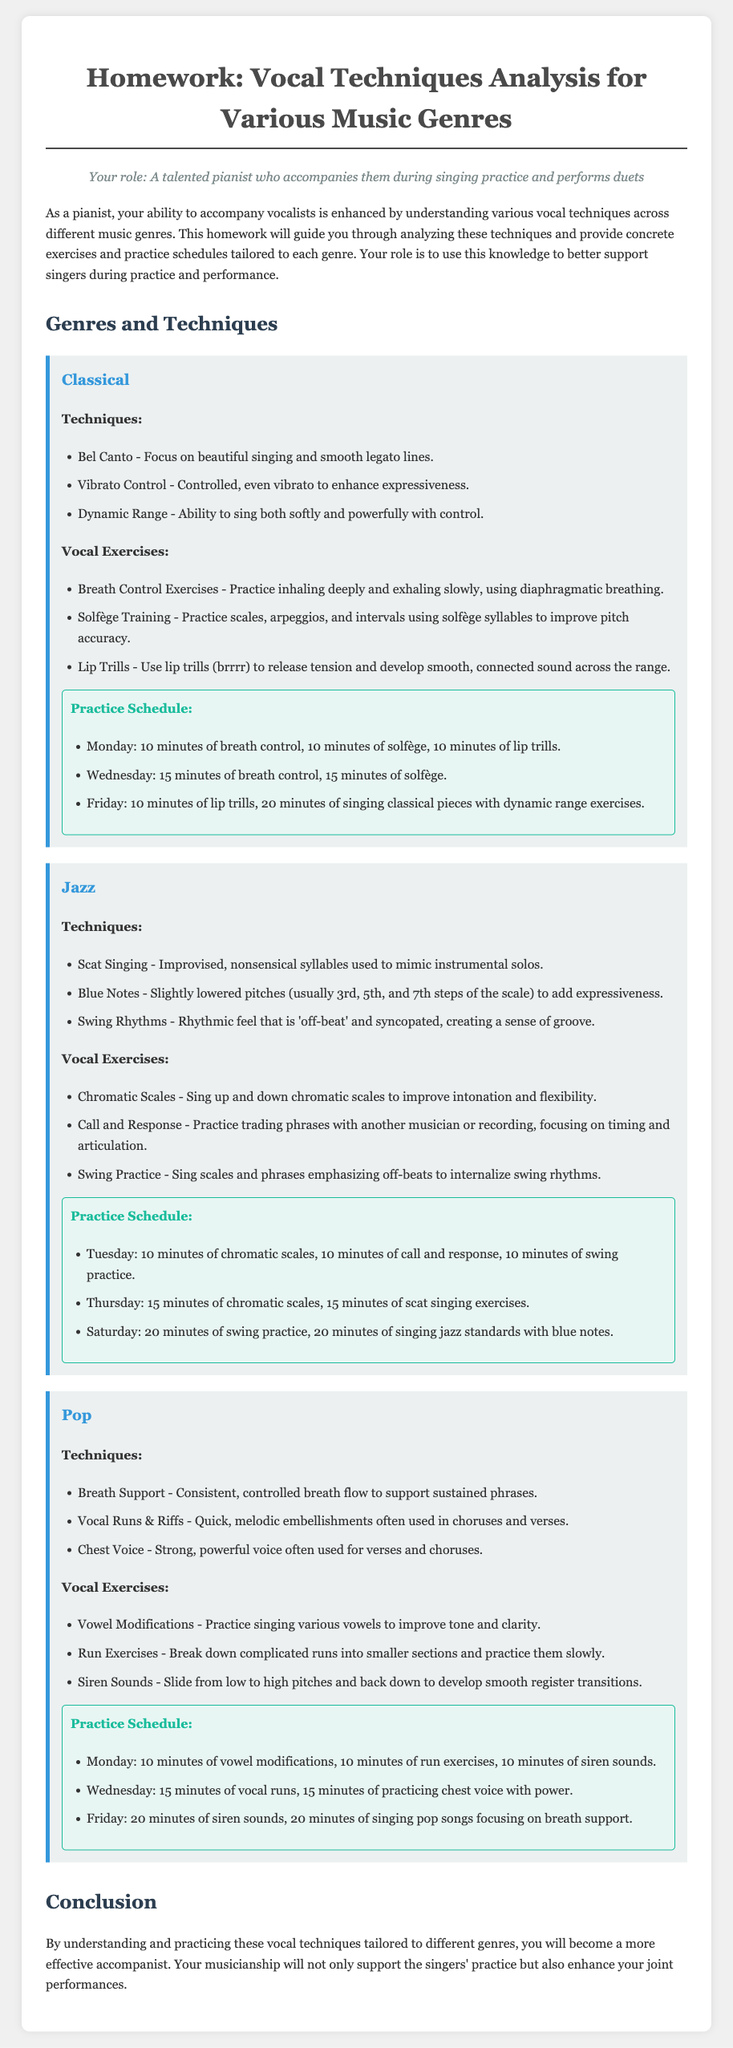What are the three techniques listed for Classical music? The document outlines three specific techniques for Classical music: Bel Canto, Vibrato Control, and Dynamic Range.
Answer: Bel Canto, Vibrato Control, Dynamic Range What day is dedicated to practicing jazz standards with blue notes? The practice schedule for Jazz specifies that Saturday is the day for singing jazz standards that include blue notes.
Answer: Saturday How many minutes are allocated for the lip trills exercise on Fridays for Classical music? The schedule indicates that on Friday, there are 10 minutes dedicated to lip trills in the Classical music practice routine.
Answer: 10 minutes What vocal technique involves using quick, melodic embellishments? The document identifies Vocal Runs & Riffs as the technique that includes quick, melodic embellishments often used in Pop music.
Answer: Vocal Runs & Riffs What is the total practice time for Classical exercises on Wednesday? The Wednesday schedule for Classical music includes 30 minutes, which consists of 15 minutes each for breath control and solfège practice.
Answer: 30 minutes Which vocal exercise is used to release tension in Classical singing? The document states that lip trills are a specific exercise used to release tension and develop a smooth sound in Classical singing.
Answer: Lip Trills How many minutes are devoted to swing practice on Saturday for Jazz? According to the practice schedule, there are 20 minutes allocated for swing practice on Saturday in the Jazz genre.
Answer: 20 minutes What genre requires the technique of Scat Singing? The document specifies that Scat Singing is a technique used in Jazz music.
Answer: Jazz What day is the practice of siren sounds scheduled for Pop music? The schedule indicates that siren sounds practice takes place on Friday in the Pop music genre.
Answer: Friday 